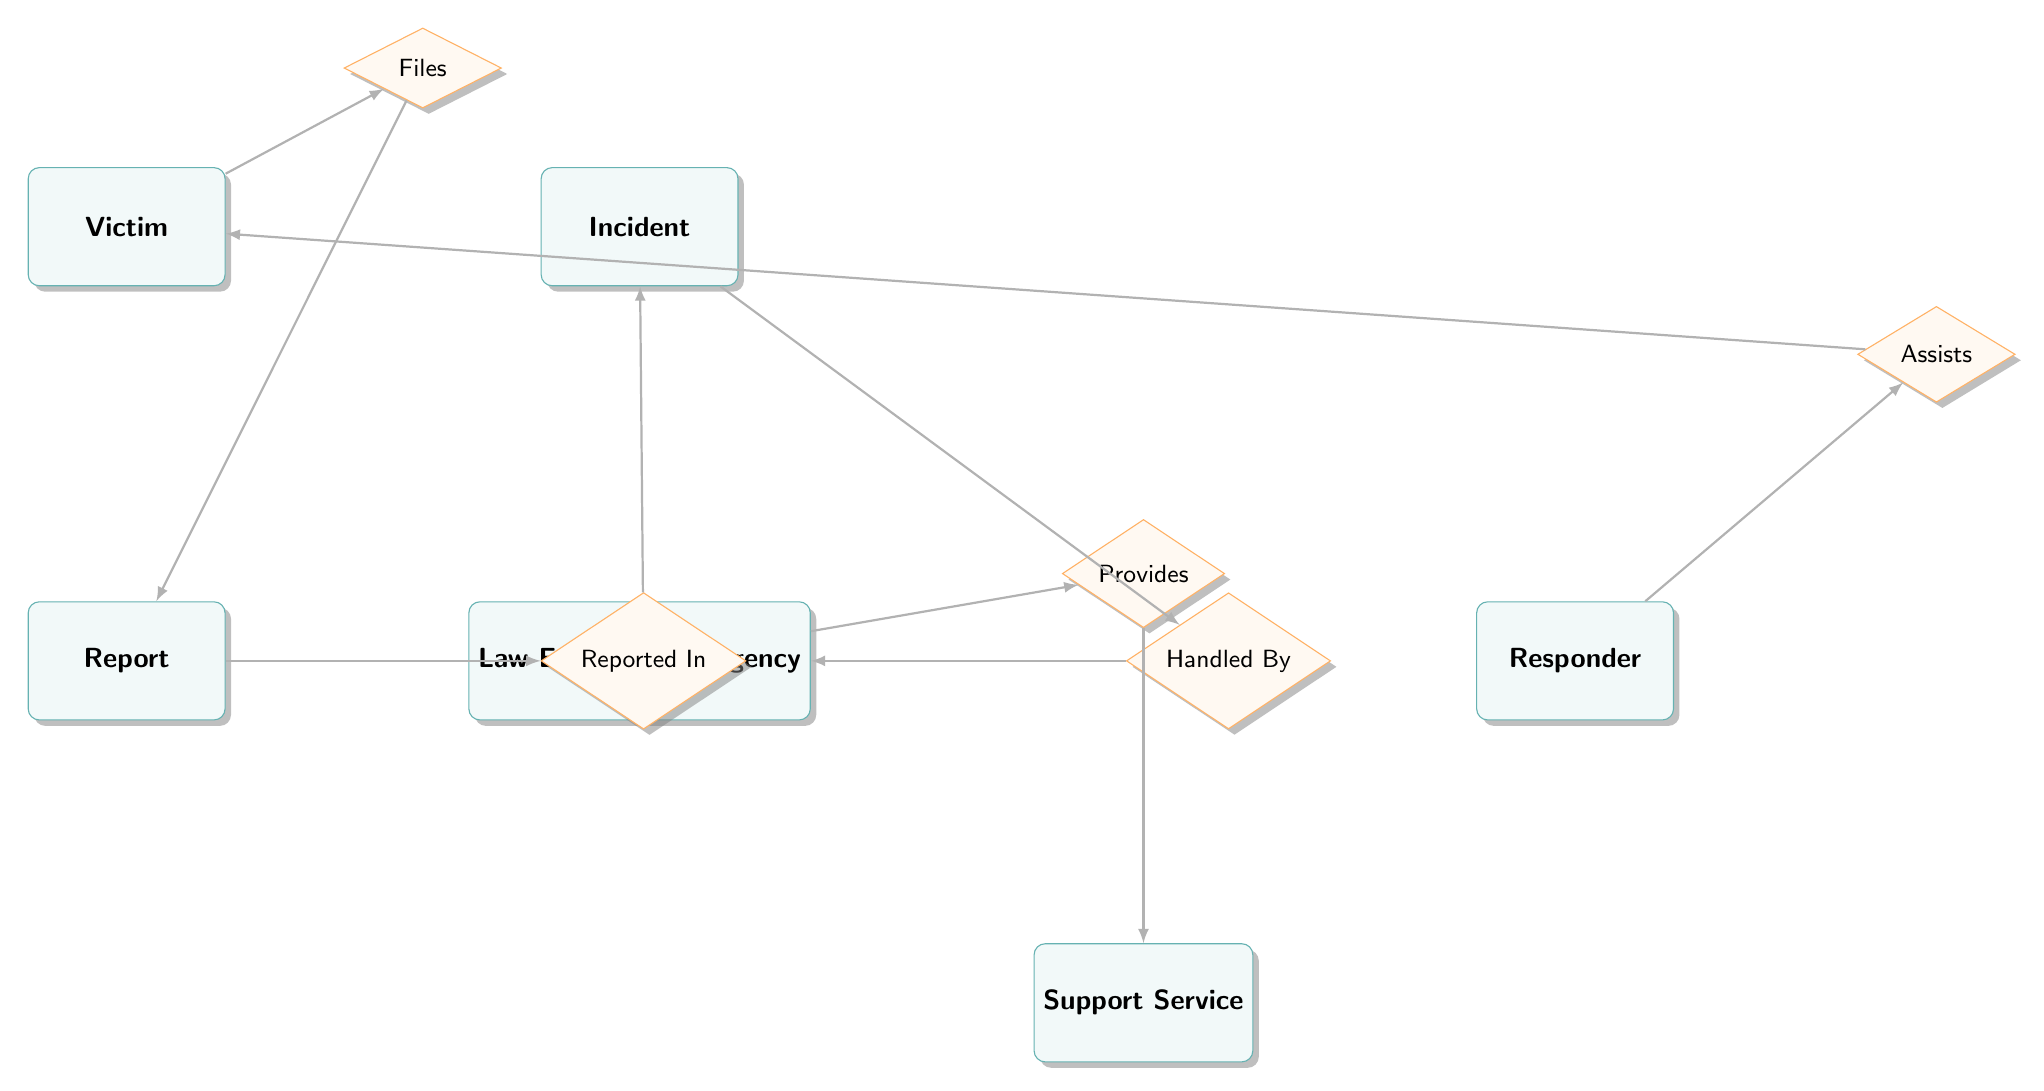What entities are included in the diagram? The diagram contains six entities: Victim, Incident, Report, Law Enforcement Agency, Support Service, and Responder.
Answer: Victim, Incident, Report, Law Enforcement Agency, Support Service, Responder How many relationships are shown in the diagram? There are five relationships in the diagram: Files, Reported In, Handled By, Provides, and Assists.
Answer: Five Which entity is associated with the relationship "Handled By"? The entity associated with the "Handled By" relationship is the Law Enforcement Agency.
Answer: Law Enforcement Agency What attribute is shared between the entities Report and Incident? The attribute shared between Report and Incident is Incident_ID, as indicated in the "Reported In" relationship.
Answer: Incident_ID Which entity does the relationship "Assists" involve? The "Assists" relationship involves the Responder and the Victim entities.
Answer: Responder and Victim How does a Victim report an Incident according to the diagram? A Victim files a Report, which is represented by the relationship "Files" connecting Victim and Report, and then this Report is linked to an Incident through "Reported In."
Answer: Through a Report What type of service does the Law Enforcement Agency provide? The Law Enforcement Agency provides Support Services, indicated by the "Provides" relationship connecting these two entities.
Answer: Support Services How many attributes does the Victim entity have? The Victim entity has five attributes: Victim_ID, Name, Age, Gender, and Contact_Info.
Answer: Five Which relationship indicates that an Incident is handled by a specific agency? The relationship that indicates an Incident is handled by a specific agency is "Handled By."
Answer: Handled By 